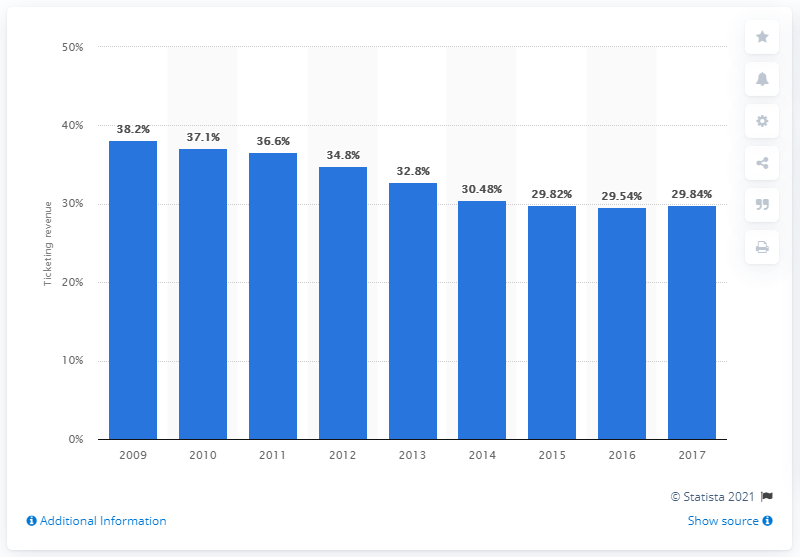Point out several critical features in this image. In 2017, MLB generated approximately 29.84% of its revenue from gate receipts. 